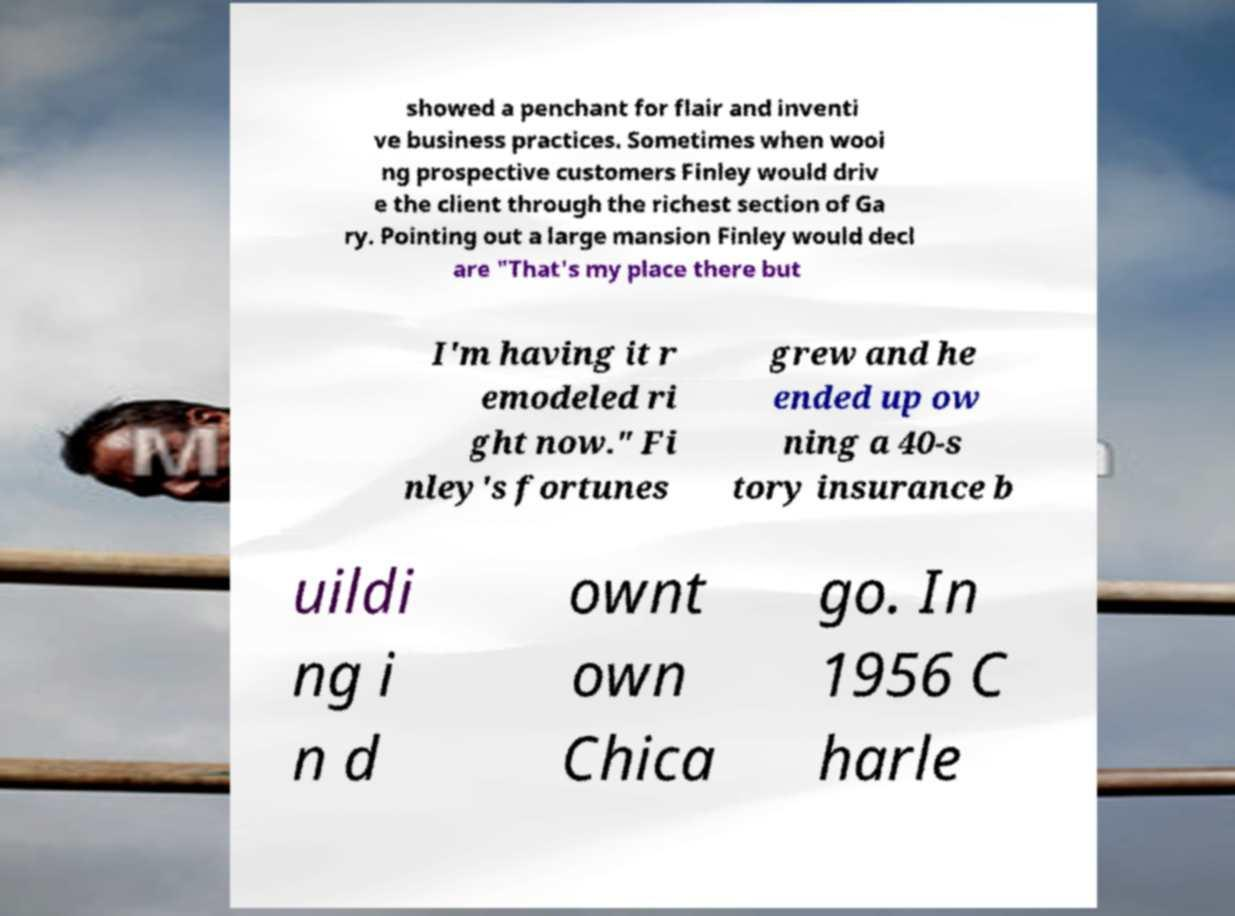What messages or text are displayed in this image? I need them in a readable, typed format. showed a penchant for flair and inventi ve business practices. Sometimes when wooi ng prospective customers Finley would driv e the client through the richest section of Ga ry. Pointing out a large mansion Finley would decl are "That's my place there but I'm having it r emodeled ri ght now." Fi nley's fortunes grew and he ended up ow ning a 40-s tory insurance b uildi ng i n d ownt own Chica go. In 1956 C harle 